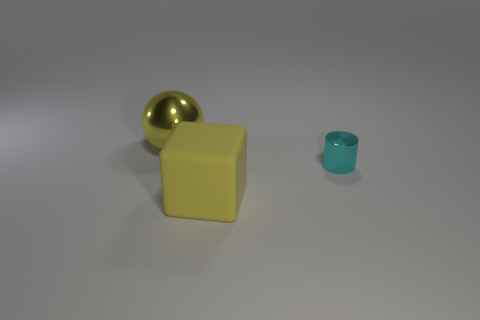There is a sphere that is the same color as the big matte block; what size is it?
Offer a very short reply. Large. Is there anything else that has the same size as the cyan cylinder?
Offer a very short reply. No. What material is the large cube that is the same color as the sphere?
Make the answer very short. Rubber. Does the shiny ball behind the shiny cylinder have the same color as the big thing that is in front of the large shiny ball?
Your answer should be compact. Yes. There is a object that is the same size as the sphere; what material is it?
Ensure brevity in your answer.  Rubber. There is a big yellow object that is to the left of the big yellow thing that is to the right of the object behind the tiny object; what shape is it?
Your response must be concise. Sphere. What is the shape of the other object that is the same size as the yellow rubber object?
Keep it short and to the point. Sphere. What number of tiny cyan objects are on the left side of the thing on the right side of the thing in front of the small metal cylinder?
Keep it short and to the point. 0. Is the number of tiny metallic things in front of the yellow ball greater than the number of rubber cubes that are to the left of the yellow block?
Give a very brief answer. Yes. How many things are either large things to the right of the large shiny sphere or large objects in front of the tiny cyan thing?
Offer a terse response. 1. 